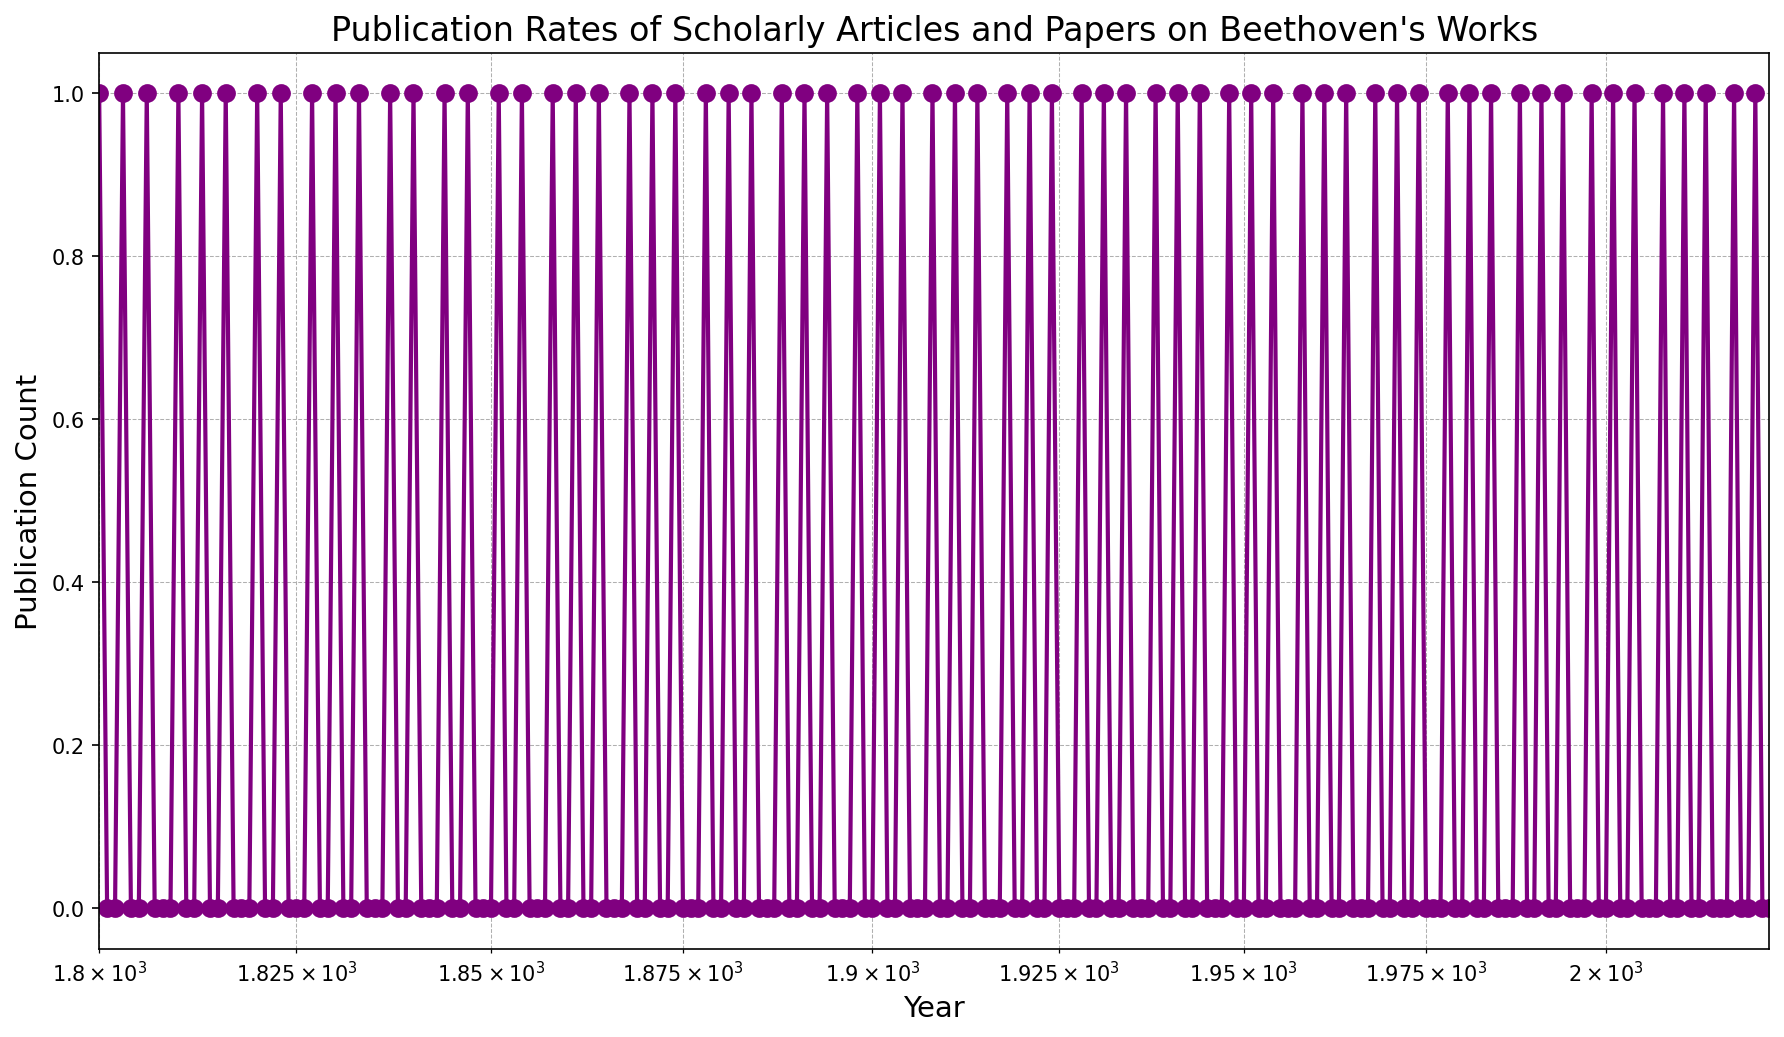What pattern do we observe in the early 19th century regarding the publication rates of scholarly articles on Beethoven's works? By examining the figure, we can see that the publication rate from 1800 to 1825 is quite low and irregular, with most of the years having zero publications and only a few years having one publication.
Answer: Irregular with very low rates Which decades have the highest publication counts? By scanning through the x-axis and checking the number of publication points, we observe that the decades closest to the present, specifically the late 20th century and early 21st century, show higher counts.
Answer: Late 20th century and early 21st century Is there any noticeable trend in publication counts over the entire period? Observing the entire logscale plot, the publication counts seem to increase towards the present, indicating a general upward trend in the number of publications over time.
Answer: General upward trend In which year(s) do we observe a break in the pattern with zero publications after a series of publications? Specific points show a break in publication, such as post-1820, 1901, and 2001, where one or more continuous years feature zero publications.
Answer: Post-1820, 1901, and 2001 Are there periods with consistent gaps in publication activity? If so, when? Notably, throughout the 19th century, consistent gaps can be observed where publications occur every few years with intervals of zero publications, such as between 1801-1802 and 1804-1805.
Answer: Throughout the 19th century What is the average publication rate from 1800 to 1900? From 1800 to 1900, there are 34 non-zero publication years. The average publication rate can be calculated as 34/100 = 0.34 publications per year.
Answer: 0.34 publications per year Does any specific year stand out in terms of publication rate? Since the publication count typically remains at 1 when present, no specific year stands out in terms of having a significantly higher rate than others, making the publication rate consistent across individual active years.
Answer: No specific year stands out Are there periods where publications seem more clustered together? From examining the plot, one can observe that during the late 20th century and early 21st century, publication occurrences appear to be more clustered compared to earlier times.
Answer: Late 20th and early 21st century What can we infer about the scholarly interest in Beethoven's works over time? The upward trend in publication counts as we approach the present suggests increasing scholarly interest in Beethoven's works over time.
Answer: Increasing interest over time 